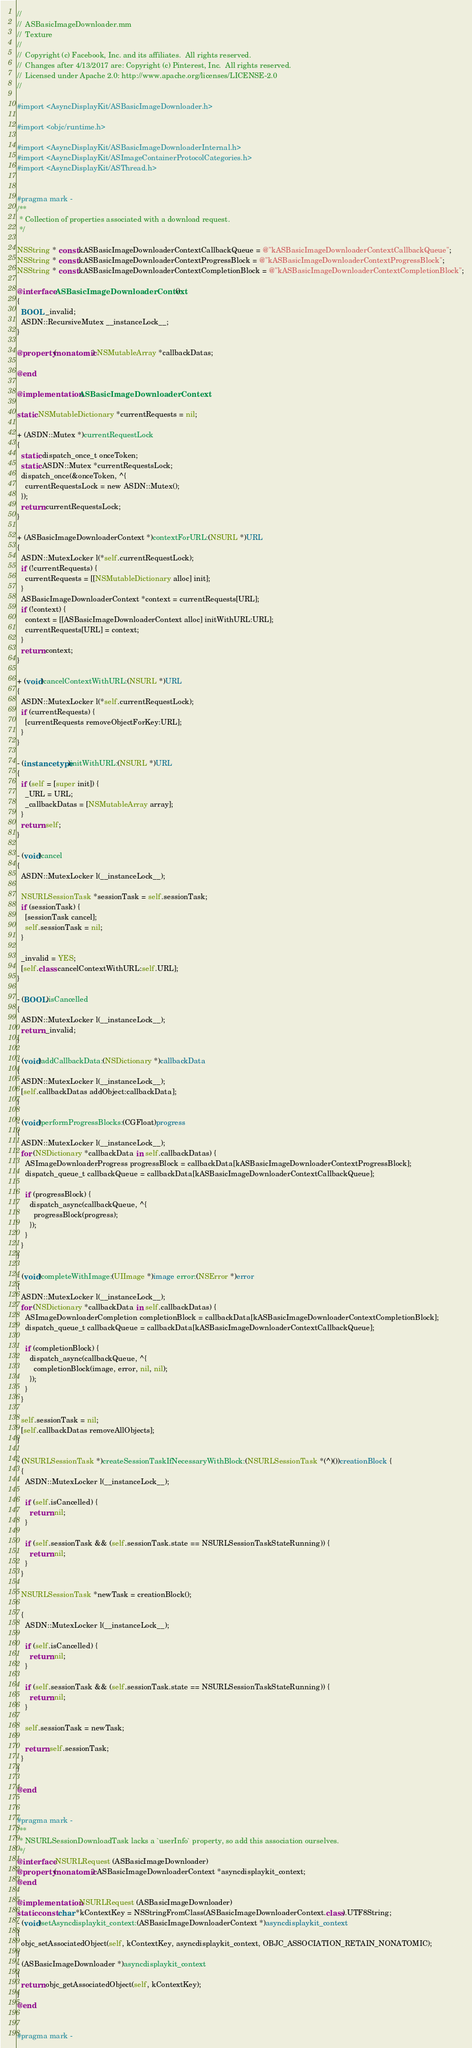Convert code to text. <code><loc_0><loc_0><loc_500><loc_500><_ObjectiveC_>//
//  ASBasicImageDownloader.mm
//  Texture
//
//  Copyright (c) Facebook, Inc. and its affiliates.  All rights reserved.
//  Changes after 4/13/2017 are: Copyright (c) Pinterest, Inc.  All rights reserved.
//  Licensed under Apache 2.0: http://www.apache.org/licenses/LICENSE-2.0
//

#import <AsyncDisplayKit/ASBasicImageDownloader.h>

#import <objc/runtime.h>

#import <AsyncDisplayKit/ASBasicImageDownloaderInternal.h>
#import <AsyncDisplayKit/ASImageContainerProtocolCategories.h>
#import <AsyncDisplayKit/ASThread.h>


#pragma mark -
/**
 * Collection of properties associated with a download request.
 */

NSString * const kASBasicImageDownloaderContextCallbackQueue = @"kASBasicImageDownloaderContextCallbackQueue";
NSString * const kASBasicImageDownloaderContextProgressBlock = @"kASBasicImageDownloaderContextProgressBlock";
NSString * const kASBasicImageDownloaderContextCompletionBlock = @"kASBasicImageDownloaderContextCompletionBlock";

@interface ASBasicImageDownloaderContext ()
{
  BOOL _invalid;
  ASDN::RecursiveMutex __instanceLock__;
}

@property (nonatomic) NSMutableArray *callbackDatas;

@end

@implementation ASBasicImageDownloaderContext

static NSMutableDictionary *currentRequests = nil;

+ (ASDN::Mutex *)currentRequestLock
{
  static dispatch_once_t onceToken;
  static ASDN::Mutex *currentRequestsLock;
  dispatch_once(&onceToken, ^{
    currentRequestsLock = new ASDN::Mutex();
  });
  return currentRequestsLock;
}

+ (ASBasicImageDownloaderContext *)contextForURL:(NSURL *)URL
{
  ASDN::MutexLocker l(*self.currentRequestLock);
  if (!currentRequests) {
    currentRequests = [[NSMutableDictionary alloc] init];
  }
  ASBasicImageDownloaderContext *context = currentRequests[URL];
  if (!context) {
    context = [[ASBasicImageDownloaderContext alloc] initWithURL:URL];
    currentRequests[URL] = context;
  }
  return context;
}

+ (void)cancelContextWithURL:(NSURL *)URL
{
  ASDN::MutexLocker l(*self.currentRequestLock);
  if (currentRequests) {
    [currentRequests removeObjectForKey:URL];
  }
}

- (instancetype)initWithURL:(NSURL *)URL
{
  if (self = [super init]) {
    _URL = URL;
    _callbackDatas = [NSMutableArray array];
  }
  return self;
}

- (void)cancel
{
  ASDN::MutexLocker l(__instanceLock__);

  NSURLSessionTask *sessionTask = self.sessionTask;
  if (sessionTask) {
    [sessionTask cancel];
    self.sessionTask = nil;
  }

  _invalid = YES;
  [self.class cancelContextWithURL:self.URL];
}

- (BOOL)isCancelled
{
  ASDN::MutexLocker l(__instanceLock__);
  return _invalid;
}

- (void)addCallbackData:(NSDictionary *)callbackData
{
  ASDN::MutexLocker l(__instanceLock__);
  [self.callbackDatas addObject:callbackData];
}

- (void)performProgressBlocks:(CGFloat)progress
{
  ASDN::MutexLocker l(__instanceLock__);
  for (NSDictionary *callbackData in self.callbackDatas) {
    ASImageDownloaderProgress progressBlock = callbackData[kASBasicImageDownloaderContextProgressBlock];
    dispatch_queue_t callbackQueue = callbackData[kASBasicImageDownloaderContextCallbackQueue];

    if (progressBlock) {
      dispatch_async(callbackQueue, ^{
        progressBlock(progress);
      });
    }
  }
}

- (void)completeWithImage:(UIImage *)image error:(NSError *)error
{
  ASDN::MutexLocker l(__instanceLock__);
  for (NSDictionary *callbackData in self.callbackDatas) {
    ASImageDownloaderCompletion completionBlock = callbackData[kASBasicImageDownloaderContextCompletionBlock];
    dispatch_queue_t callbackQueue = callbackData[kASBasicImageDownloaderContextCallbackQueue];

    if (completionBlock) {
      dispatch_async(callbackQueue, ^{
        completionBlock(image, error, nil, nil);
      });
    }
  }

  self.sessionTask = nil;
  [self.callbackDatas removeAllObjects];
}

- (NSURLSessionTask *)createSessionTaskIfNecessaryWithBlock:(NSURLSessionTask *(^)())creationBlock {
  {
    ASDN::MutexLocker l(__instanceLock__);

    if (self.isCancelled) {
      return nil;
    }

    if (self.sessionTask && (self.sessionTask.state == NSURLSessionTaskStateRunning)) {
      return nil;
    }
  }

  NSURLSessionTask *newTask = creationBlock();

  {
    ASDN::MutexLocker l(__instanceLock__);

    if (self.isCancelled) {
      return nil;
    }

    if (self.sessionTask && (self.sessionTask.state == NSURLSessionTaskStateRunning)) {
      return nil;
    }

    self.sessionTask = newTask;
    
    return self.sessionTask;
  }
}

@end


#pragma mark -
/**
 * NSURLSessionDownloadTask lacks a `userInfo` property, so add this association ourselves.
 */
@interface NSURLRequest (ASBasicImageDownloader)
@property (nonatomic) ASBasicImageDownloaderContext *asyncdisplaykit_context;
@end

@implementation NSURLRequest (ASBasicImageDownloader)
static const char *kContextKey = NSStringFromClass(ASBasicImageDownloaderContext.class).UTF8String;
- (void)setAsyncdisplaykit_context:(ASBasicImageDownloaderContext *)asyncdisplaykit_context
{
  objc_setAssociatedObject(self, kContextKey, asyncdisplaykit_context, OBJC_ASSOCIATION_RETAIN_NONATOMIC);
}
- (ASBasicImageDownloader *)asyncdisplaykit_context
{
  return objc_getAssociatedObject(self, kContextKey);
}
@end


#pragma mark -</code> 